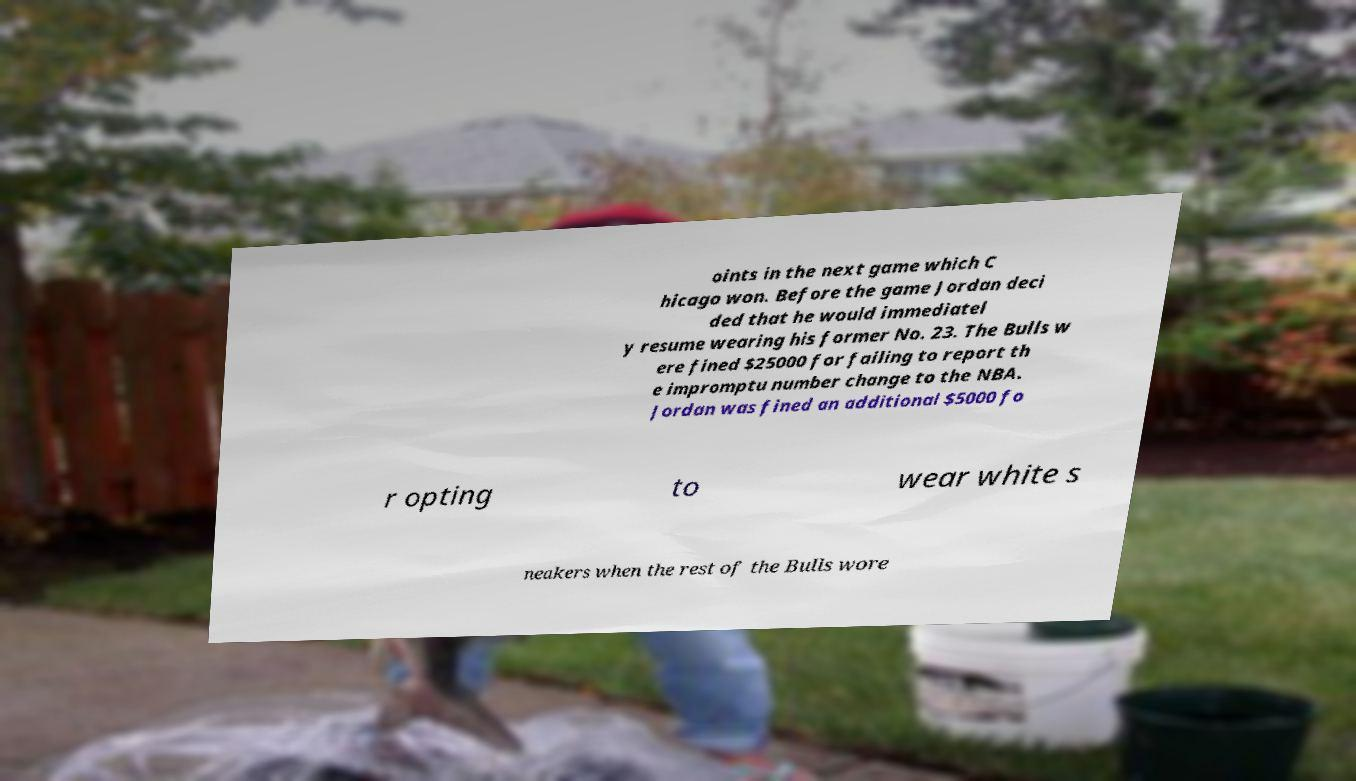Can you accurately transcribe the text from the provided image for me? oints in the next game which C hicago won. Before the game Jordan deci ded that he would immediatel y resume wearing his former No. 23. The Bulls w ere fined $25000 for failing to report th e impromptu number change to the NBA. Jordan was fined an additional $5000 fo r opting to wear white s neakers when the rest of the Bulls wore 